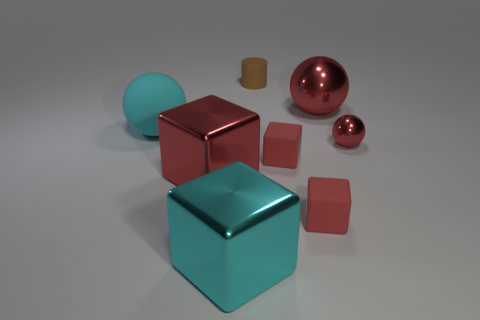How many small brown rubber things are to the right of the small shiny object?
Keep it short and to the point. 0. What material is the big red cube?
Offer a terse response. Metal. Is the color of the tiny sphere the same as the large metal ball?
Keep it short and to the point. Yes. Are there fewer brown matte cylinders in front of the large matte sphere than large cyan spheres?
Provide a succinct answer. Yes. There is a large ball that is to the right of the tiny cylinder; what is its color?
Ensure brevity in your answer.  Red. There is a brown thing; what shape is it?
Your answer should be compact. Cylinder. There is a big red metal thing that is behind the red metallic thing that is in front of the tiny red ball; is there a large object left of it?
Offer a terse response. Yes. There is a tiny cube that is in front of the small red rubber object that is behind the metal object that is left of the cyan metallic cube; what is its color?
Provide a succinct answer. Red. What material is the big red object that is the same shape as the big cyan rubber object?
Provide a succinct answer. Metal. There is a cyan object to the right of the large red object that is on the left side of the brown cylinder; what is its size?
Provide a succinct answer. Large. 